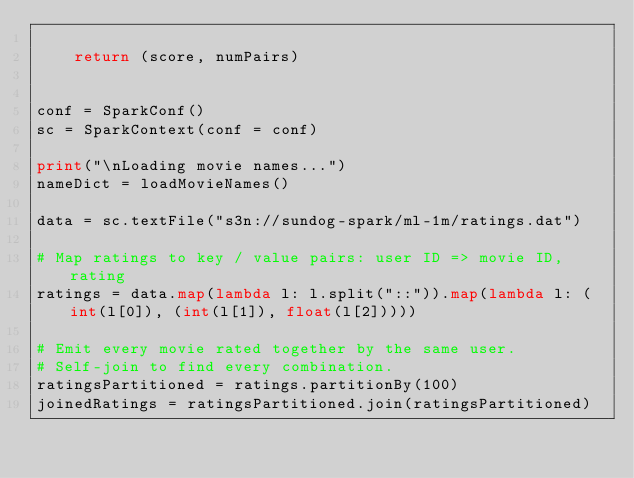<code> <loc_0><loc_0><loc_500><loc_500><_Python_>
    return (score, numPairs)


conf = SparkConf()
sc = SparkContext(conf = conf)

print("\nLoading movie names...")
nameDict = loadMovieNames()

data = sc.textFile("s3n://sundog-spark/ml-1m/ratings.dat")

# Map ratings to key / value pairs: user ID => movie ID, rating
ratings = data.map(lambda l: l.split("::")).map(lambda l: (int(l[0]), (int(l[1]), float(l[2]))))

# Emit every movie rated together by the same user.
# Self-join to find every combination.
ratingsPartitioned = ratings.partitionBy(100)
joinedRatings = ratingsPartitioned.join(ratingsPartitioned)
</code> 